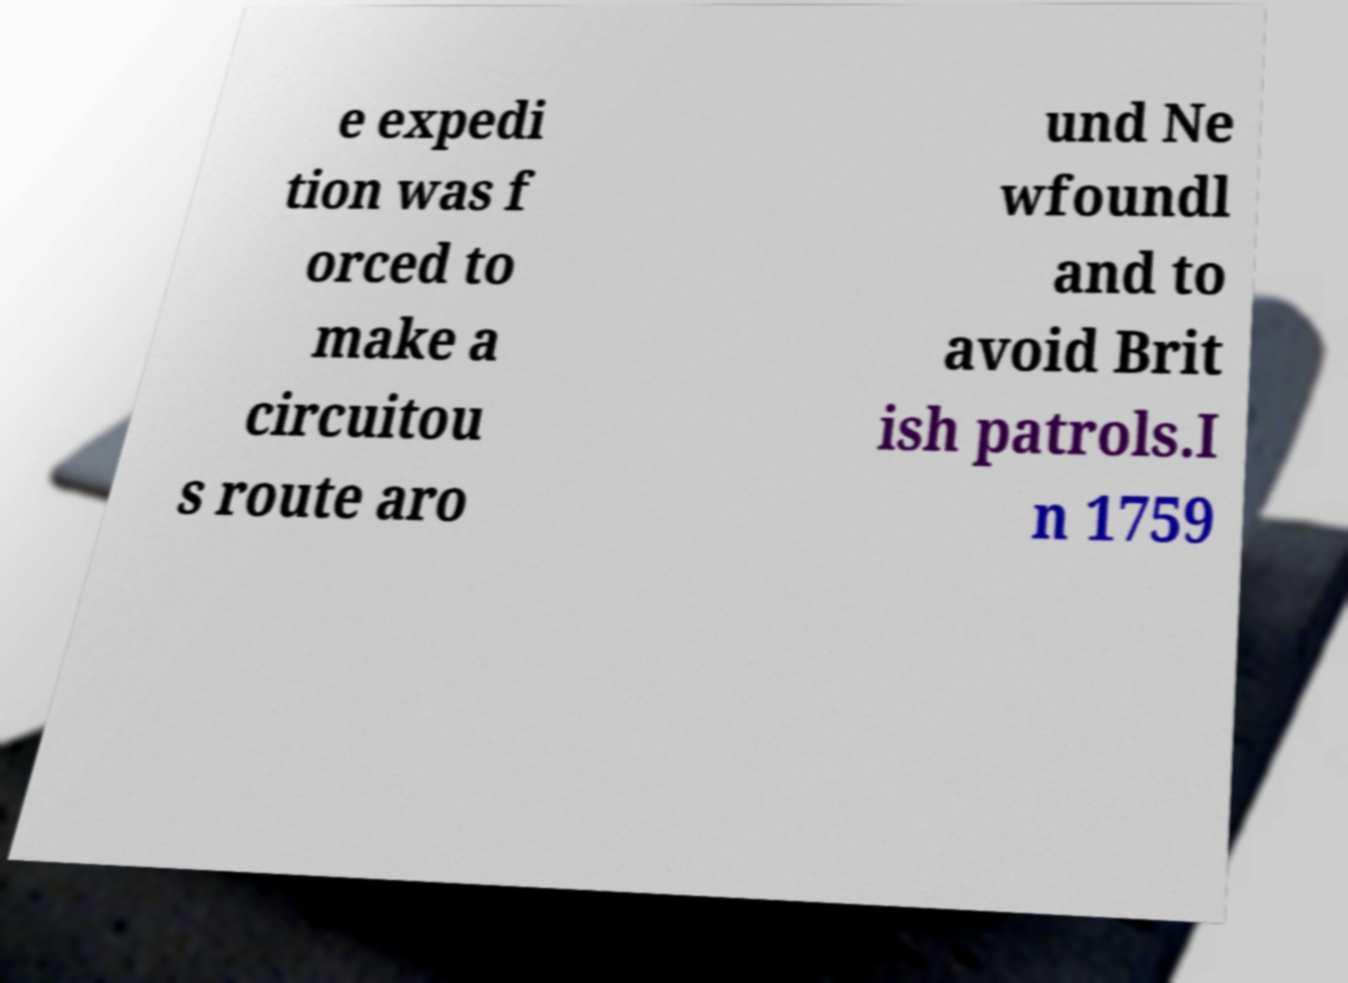For documentation purposes, I need the text within this image transcribed. Could you provide that? e expedi tion was f orced to make a circuitou s route aro und Ne wfoundl and to avoid Brit ish patrols.I n 1759 